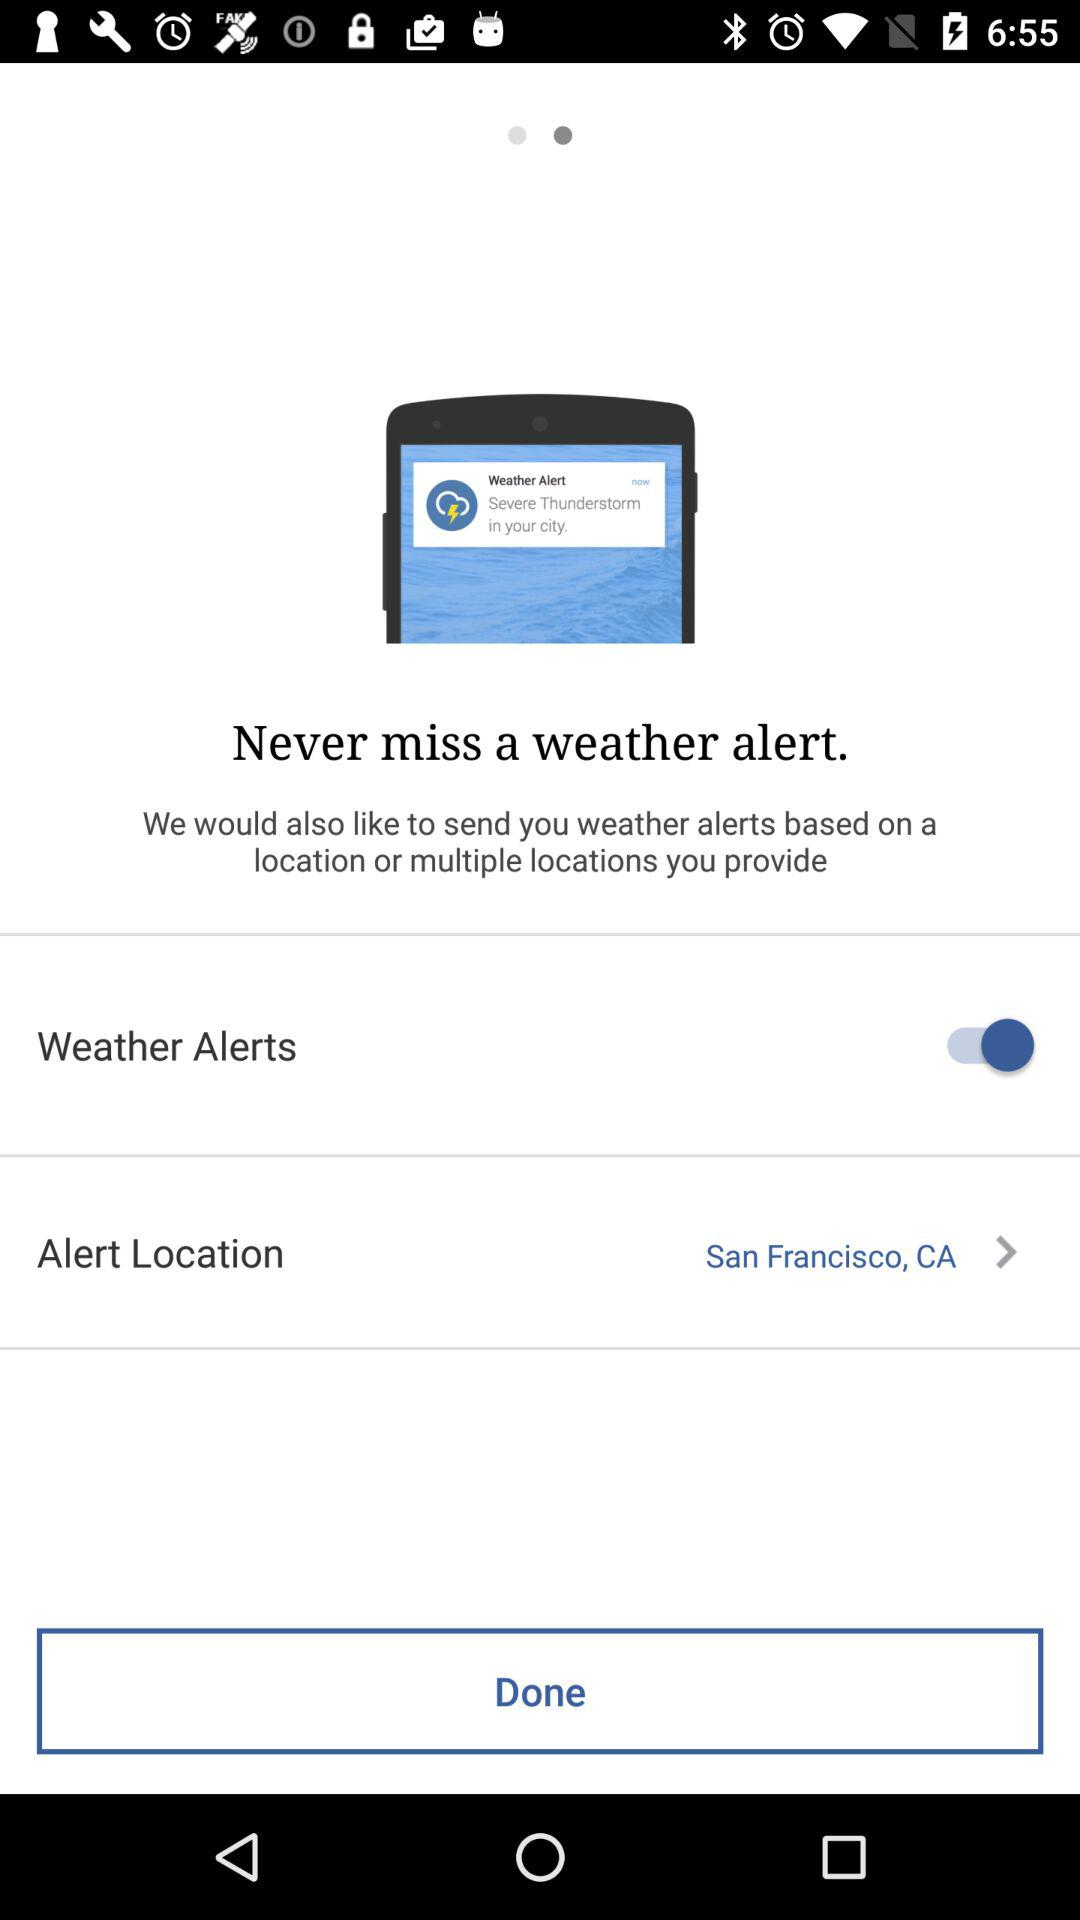How many weather alerts get sent daily?
When the provided information is insufficient, respond with <no answer>. <no answer> 